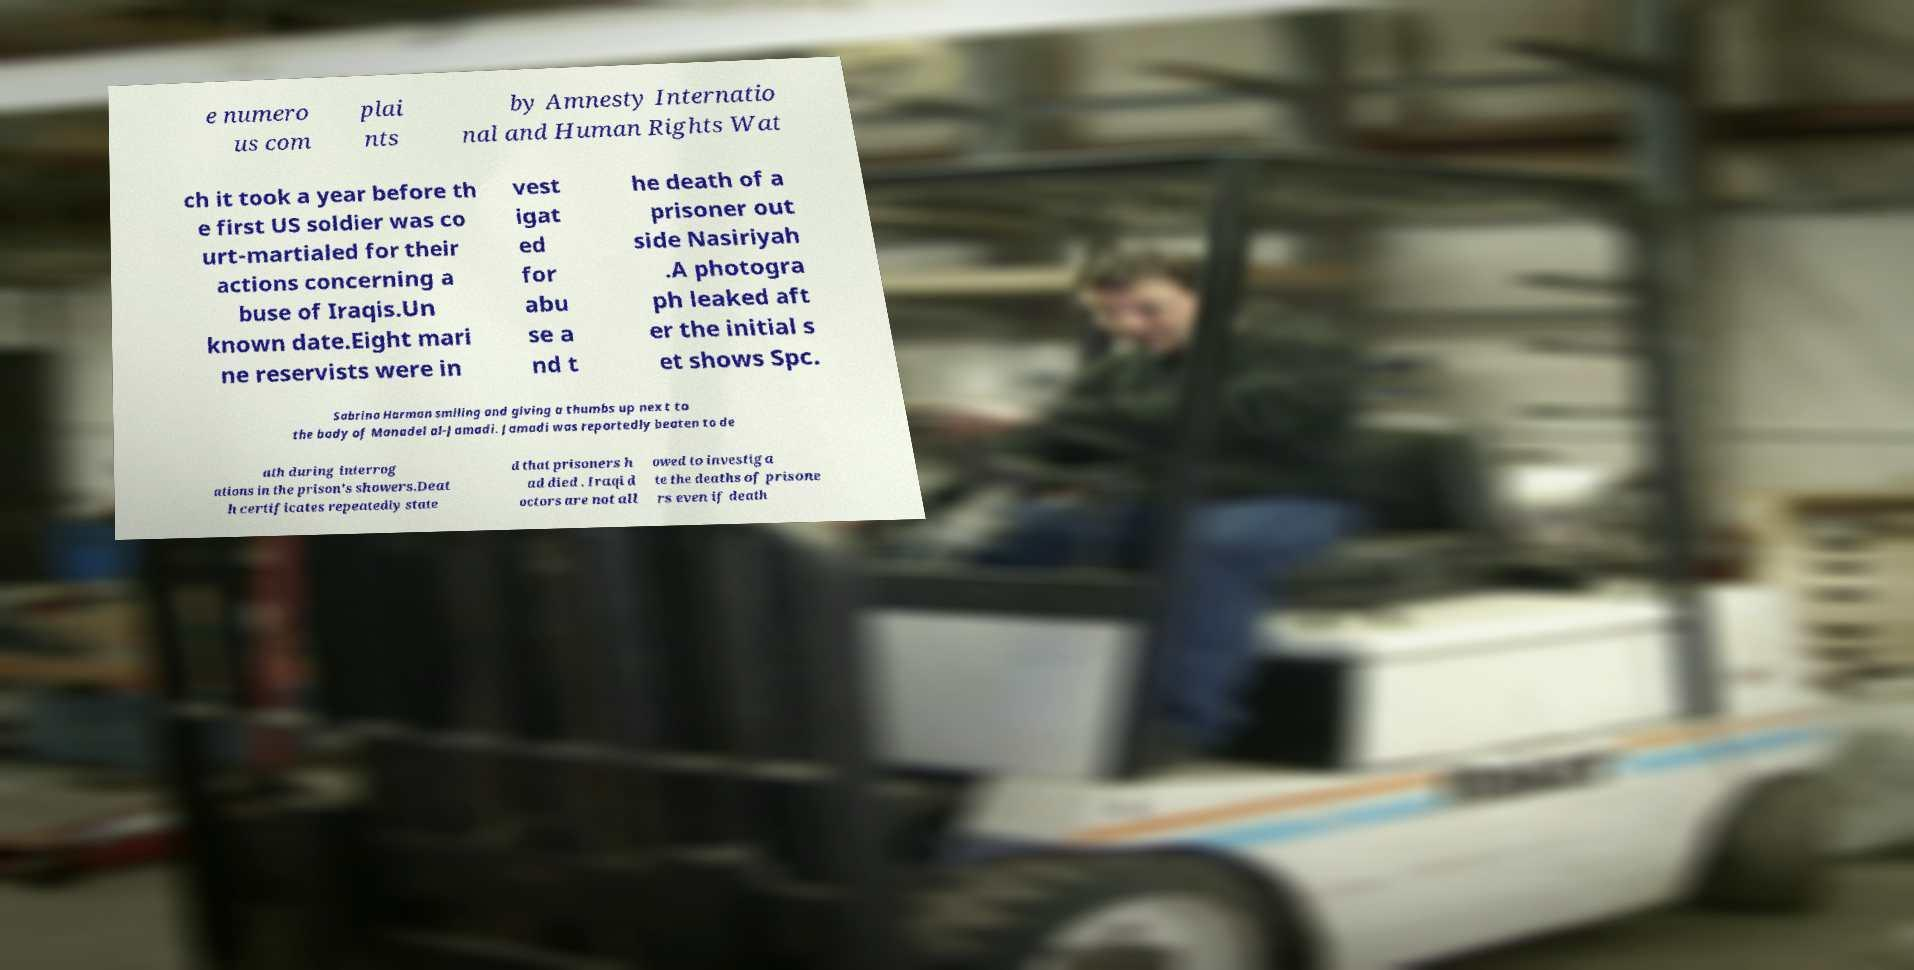There's text embedded in this image that I need extracted. Can you transcribe it verbatim? e numero us com plai nts by Amnesty Internatio nal and Human Rights Wat ch it took a year before th e first US soldier was co urt-martialed for their actions concerning a buse of Iraqis.Un known date.Eight mari ne reservists were in vest igat ed for abu se a nd t he death of a prisoner out side Nasiriyah .A photogra ph leaked aft er the initial s et shows Spc. Sabrina Harman smiling and giving a thumbs up next to the body of Manadel al-Jamadi. Jamadi was reportedly beaten to de ath during interrog ations in the prison's showers.Deat h certificates repeatedly state d that prisoners h ad died . Iraqi d octors are not all owed to investiga te the deaths of prisone rs even if death 